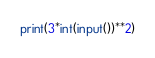<code> <loc_0><loc_0><loc_500><loc_500><_Python_>print(3*int(input())**2)</code> 